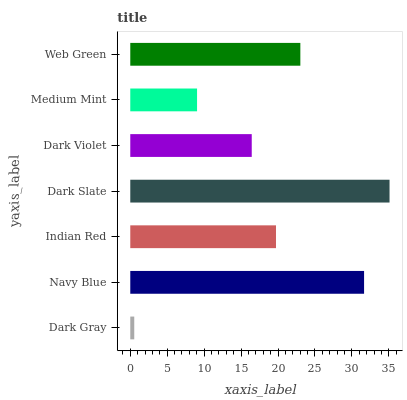Is Dark Gray the minimum?
Answer yes or no. Yes. Is Dark Slate the maximum?
Answer yes or no. Yes. Is Navy Blue the minimum?
Answer yes or no. No. Is Navy Blue the maximum?
Answer yes or no. No. Is Navy Blue greater than Dark Gray?
Answer yes or no. Yes. Is Dark Gray less than Navy Blue?
Answer yes or no. Yes. Is Dark Gray greater than Navy Blue?
Answer yes or no. No. Is Navy Blue less than Dark Gray?
Answer yes or no. No. Is Indian Red the high median?
Answer yes or no. Yes. Is Indian Red the low median?
Answer yes or no. Yes. Is Dark Violet the high median?
Answer yes or no. No. Is Medium Mint the low median?
Answer yes or no. No. 